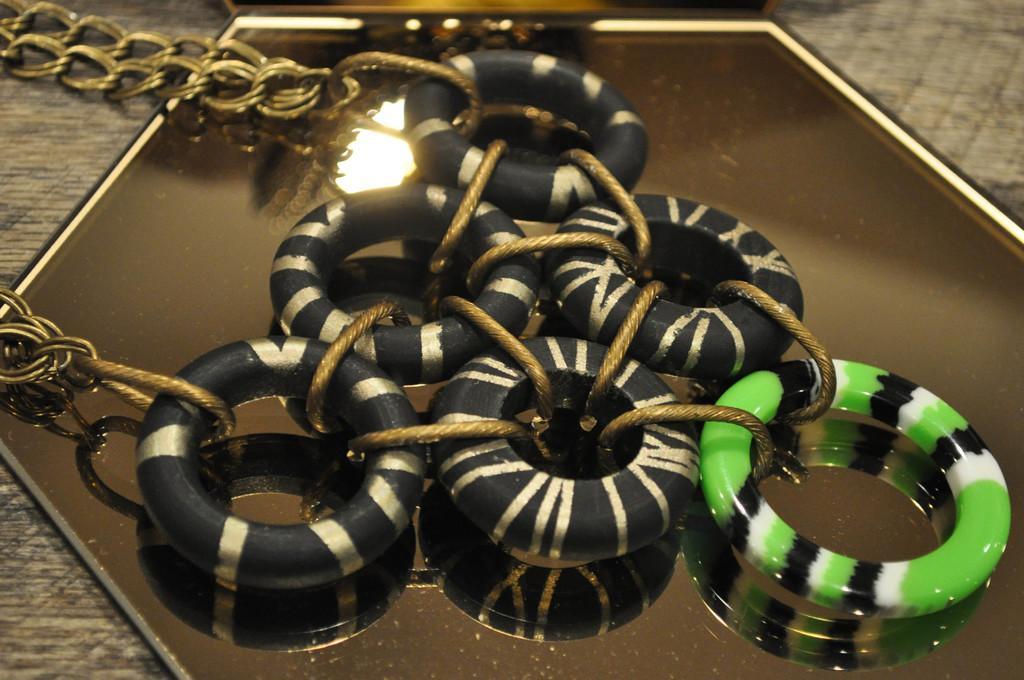Can you describe this image briefly? On this mirror there are rings and chain.  